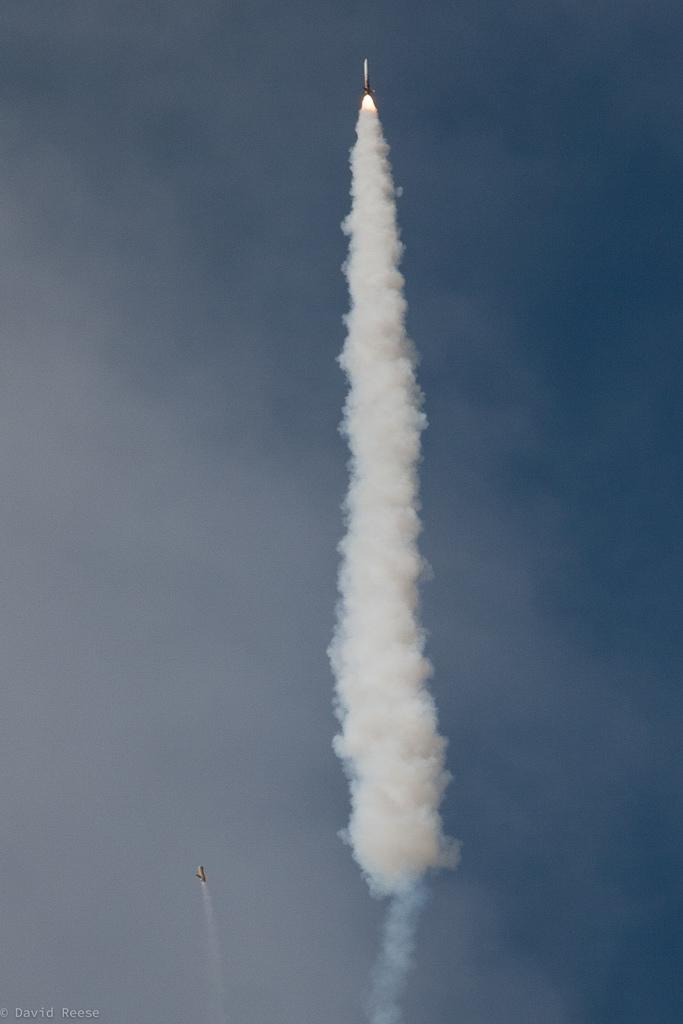What is in the air in the image? There are two rockets in the air in the image. What can be seen in the background of the image? The sky is visible in the image. What is the result of the rockets in the image? There is smoke present in the image. What type of fight is taking place in the image? There is no fight present in the image; it features two rockets in the air and smoke. Is there any water visible in the image? There is no water present in the image. 